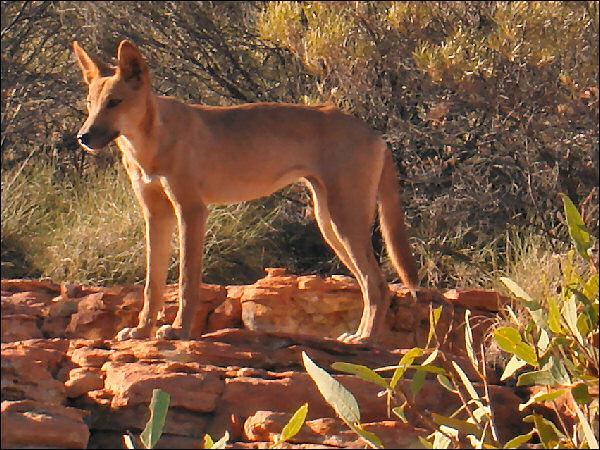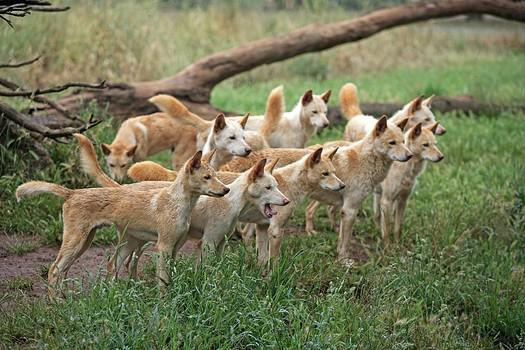The first image is the image on the left, the second image is the image on the right. For the images shown, is this caption "Each image contains exactly one wild dog." true? Answer yes or no. No. The first image is the image on the left, the second image is the image on the right. For the images displayed, is the sentence "Two wild dogs are out in the wild near a wooded area." factually correct? Answer yes or no. No. 